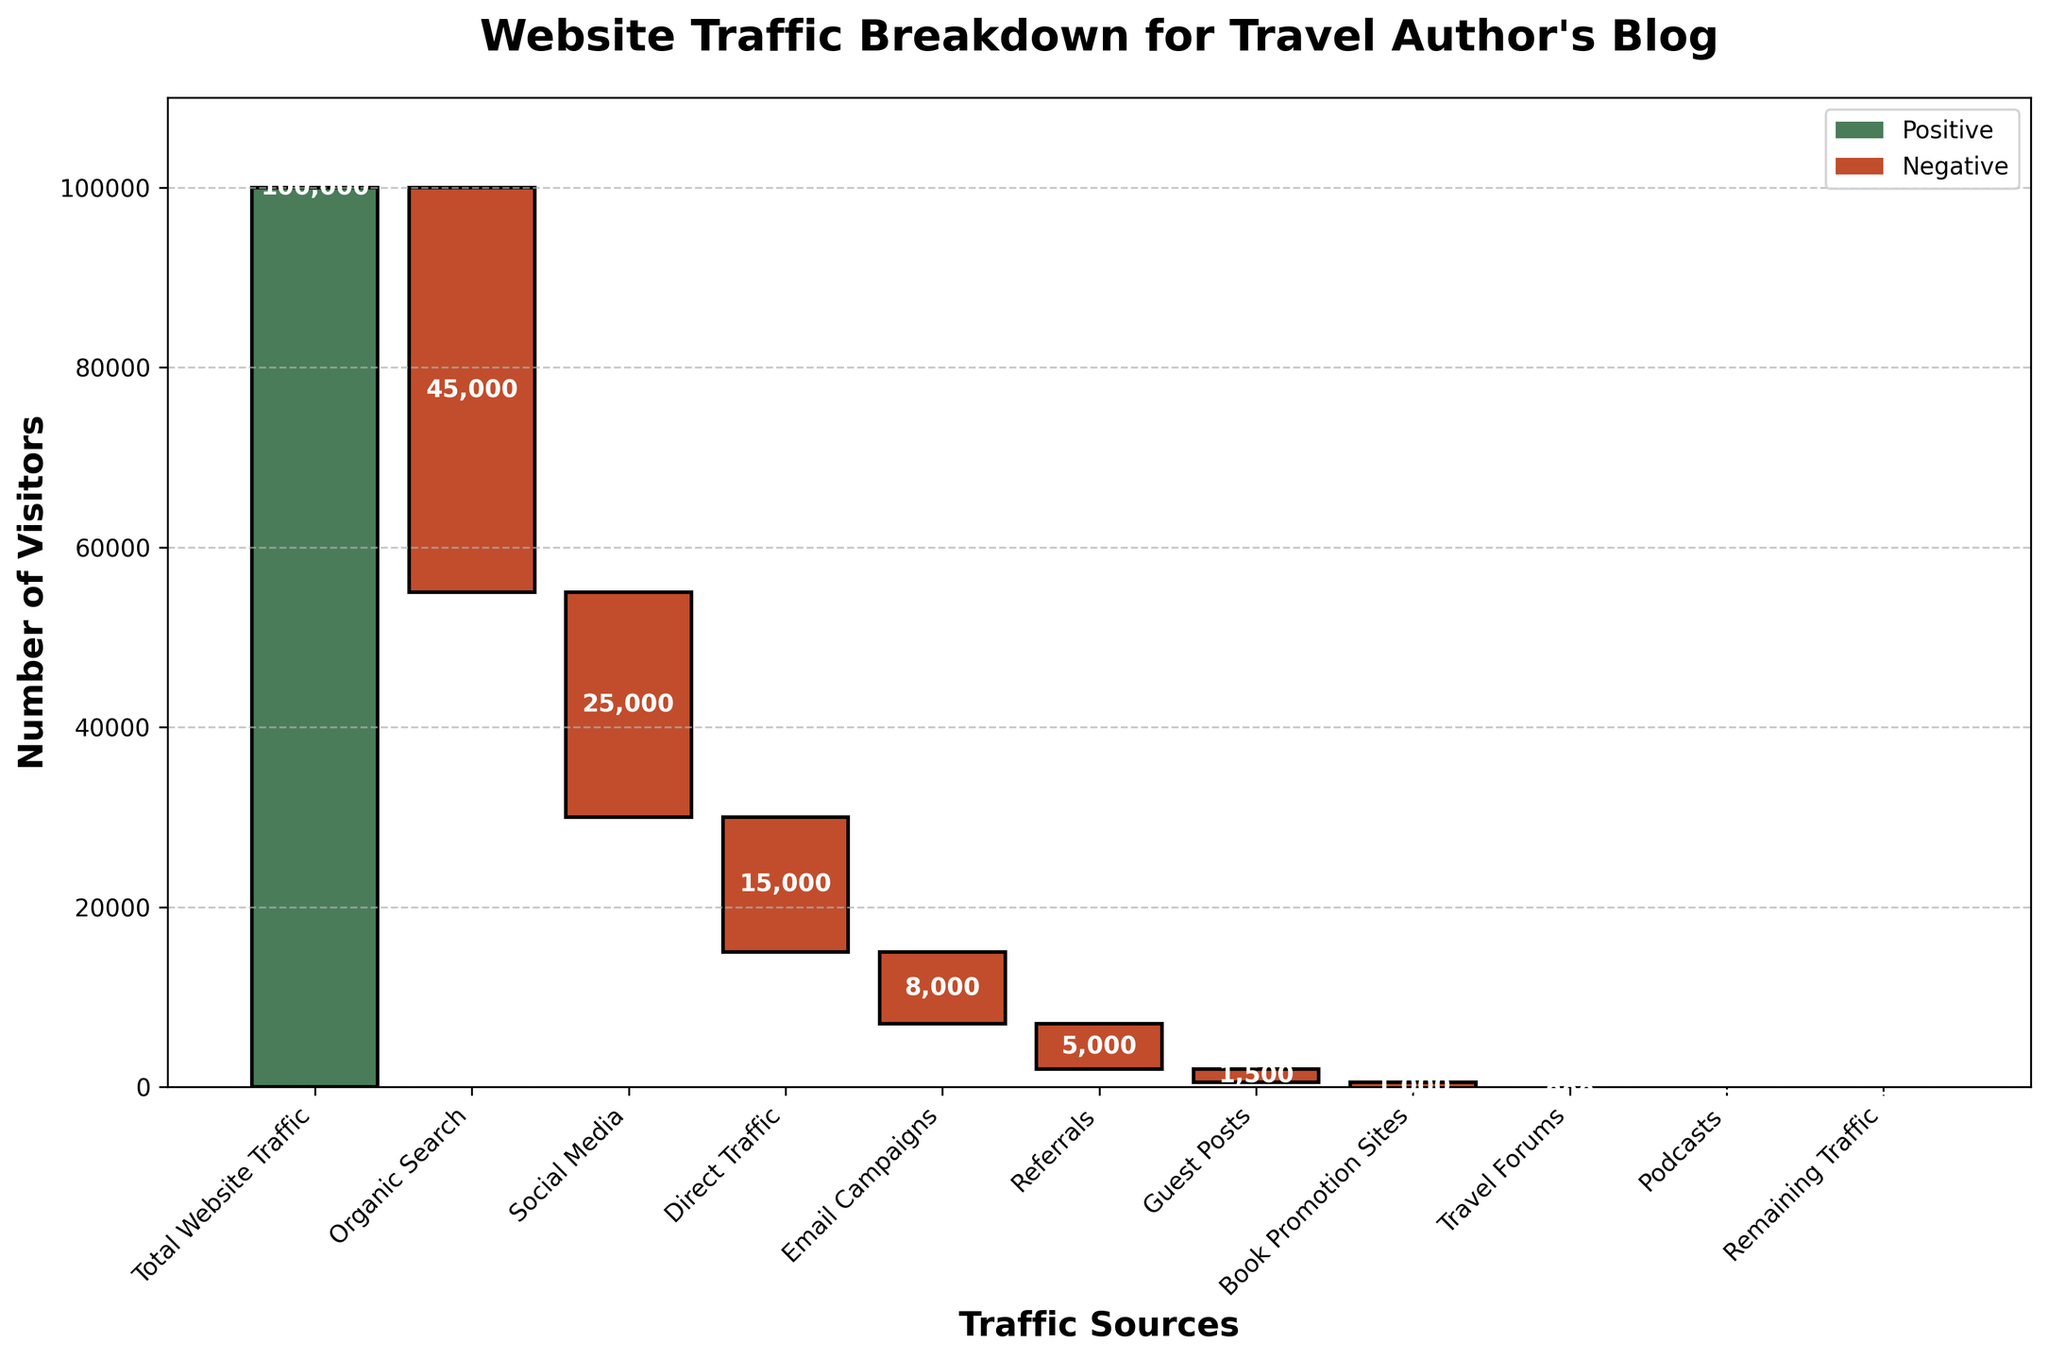what is the title of the chart? The title of any chart is typically located at the top of the graph. It provides a summary or general description of what the chart represents. In this case, the title should summarize the data being presented about the traffic sources for the blog.
Answer: "Website Traffic Breakdown for Travel Author's Blog" How many traffic sources are broken down in the chart? To determine the number of traffic sources, count the bars in the waterfall chart excluding the 'Total Website Traffic' and 'Remaining Traffic.' Each individual bar represents a distinct source.
Answer: 9 Which traffic source contributes the most to the total website traffic loss? By examining the waterfall chart, identify the source with the largest negative value (the largest red bar). This will be the source that most contributes to the traffic loss.
Answer: Organic Search What is the cumulative traffic after accounting for Social Media? Start with the 'Total Website Traffic,' subtract the value of Organic Search, and then subtract the value for Social Media. 100,000 - 45,000 - 25,000 equals the resulting cumulative traffic.
Answer: 30,000 How much traffic is lost from Direct Traffic and Email Campaigns combined? Add the values of Direct Traffic and Email Campaigns together: 15,000 + 8,000 equal the total traffic lost from these two sources.
Answer: 23,000 Which traffic source contributes the least to the total website traffic loss? Determine which red bar (negative value) is the smallest. This will be the traffic source contributing the least to the traffic loss.
Answer: Podcasts Is the traffic lost from Direct Traffic greater than the traffic lost from Referral sources? Compare the values associated with Direct Traffic and Referrals. Direct Traffic is 15,000 and Referrals is 5,000. Direct Traffic loses more.
Answer: Yes By how much is the traffic from Guest Posts greater than the traffic from Podcasts? Calculate the difference between the values of Guest Posts and Podcasts. Guest Posts = 1,500, Podcasts = 500. 1,500 - 500 equal the difference.
Answer: 1,000 How much traffic remains after all sources are accounted for? According to the chart, 'Remaining Traffic' represents the traffic left after accounting for all sources. In this case, it’s shown as 0. Follow the figure and cumulative steps if necessary.
Answer: 0 What are the positive and negative bar colors in the chart? The positive values are generally indicated by one color, and the negative values by another. Based on the instructions, positive bars are green, and negative bars are red.
Answer: Green (Positive) and Red (Negative) 